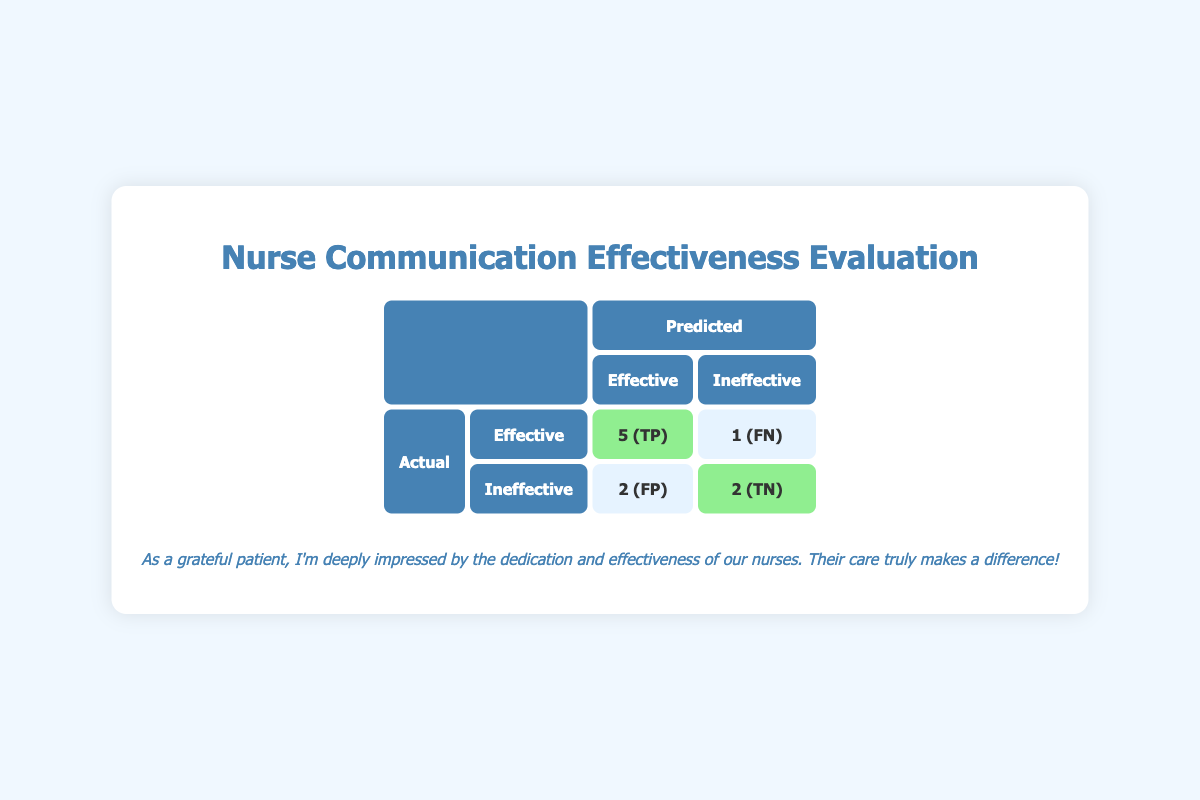What is the total number of patients whose communication sessions were evaluated? By looking at the table, we can count the total number of instances listed under "Actual" and "Predicted." There are 10 entries in total, corresponding to the 10 patients evaluated.
Answer: 10 How many patients were correctly identified as having effective communication? The "True Positive" value in the table indicates the number of cases where the communication was actually effective and predicted as such. This value is 5.
Answer: 5 What is the number of patients who were found to be ineffective but predicted as effective? In the "Ineffective" row under "Predicted," the value in the column for "Effective" represents those who were ineffective yet predicted to be effective. This value is 2.
Answer: 2 What percentage of patients were correctly identified as ineffective? The "True Negative" value is 2, indicating how many ineffective cases were correctly predicted. To find the percentage, we take (True Negatives / Total Inevective) x 100. There are 3 ineffective cases (1 False Negative + 2 True Negatives), making it (2/3)*100 = 66.67%.
Answer: 66.67% Is it true that more patients were predicted to have ineffective communication than those who actually had ineffective communication? Yes, if we compare the actual ineffective values (3) with the predicted ineffective values (4, derived from 2 True Positives + 2 False Negatives), the predicted number is higher.
Answer: Yes How many patients were misclassified as effective when they were actually ineffective? The "False Negative" value shows the patients who were ineffective yet were predicted to have effective communication. This value is 1, meaning one patient was misclassified.
Answer: 1 What is the ratio of True Positives to False Positives in this evaluation? True Positives equal 5 and False Positives equal 2. Therefore, the ratio is 5:2, which signifies how many true effective cases were found for every false classification of ineffective.
Answer: 5:2 How many instances of communication were classified as effective regardless of actual effectiveness? By adding both True Positives and False Positives, we find the total to be 5 + 2 = 7 instances classified as effective.
Answer: 7 What can be inferred about the overall effectiveness of communication based on this confusion matrix? The majority of actual effective cases were correctly identified (5 out of 6), and the False Positive rate isn’t excessively high (2 out of 8). This indicates that communication effectiveness is generally high among the evaluated patients.
Answer: Generally high effectiveness 